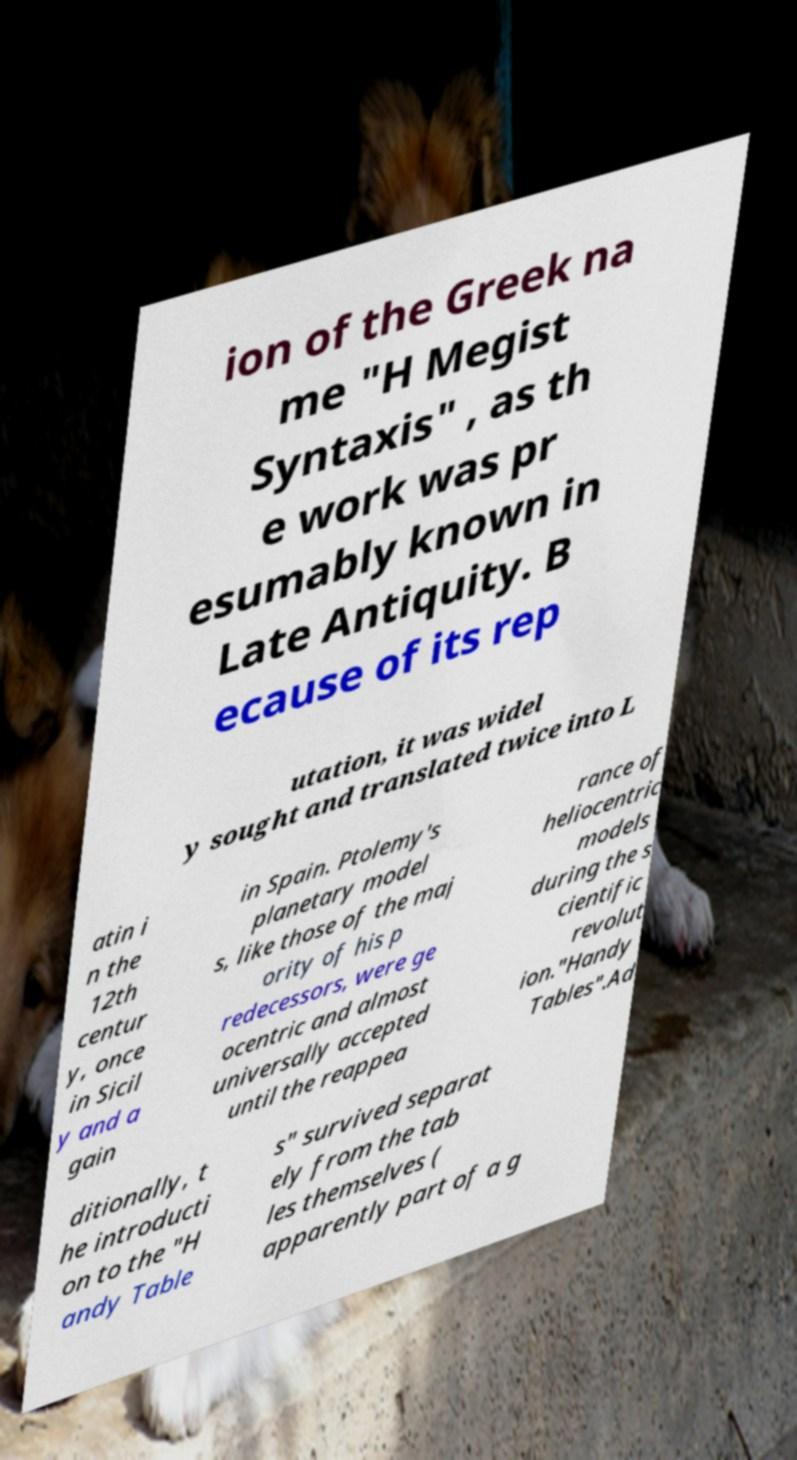Could you extract and type out the text from this image? ion of the Greek na me "H Megist Syntaxis" , as th e work was pr esumably known in Late Antiquity. B ecause of its rep utation, it was widel y sought and translated twice into L atin i n the 12th centur y, once in Sicil y and a gain in Spain. Ptolemy's planetary model s, like those of the maj ority of his p redecessors, were ge ocentric and almost universally accepted until the reappea rance of heliocentric models during the s cientific revolut ion."Handy Tables".Ad ditionally, t he introducti on to the "H andy Table s" survived separat ely from the tab les themselves ( apparently part of a g 